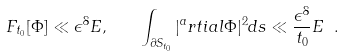<formula> <loc_0><loc_0><loc_500><loc_500>\ F _ { t _ { 0 } } [ \Phi ] \ll \epsilon ^ { 8 } E , \quad \int _ { \partial S _ { t _ { 0 } } } | ^ { a } r t i a l \Phi | ^ { 2 } d s \ll \frac { \epsilon ^ { 8 } } { t _ { 0 } } E \ .</formula> 